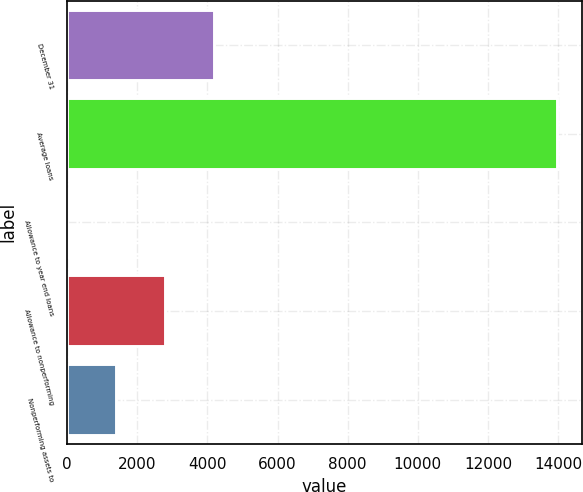Convert chart to OTSL. <chart><loc_0><loc_0><loc_500><loc_500><bar_chart><fcel>December 31<fcel>Average loans<fcel>Allowance to year end loans<fcel>Allowance to nonperforming<fcel>Nonperforming assets to<nl><fcel>4192.05<fcel>13973<fcel>0.21<fcel>2794.77<fcel>1397.49<nl></chart> 